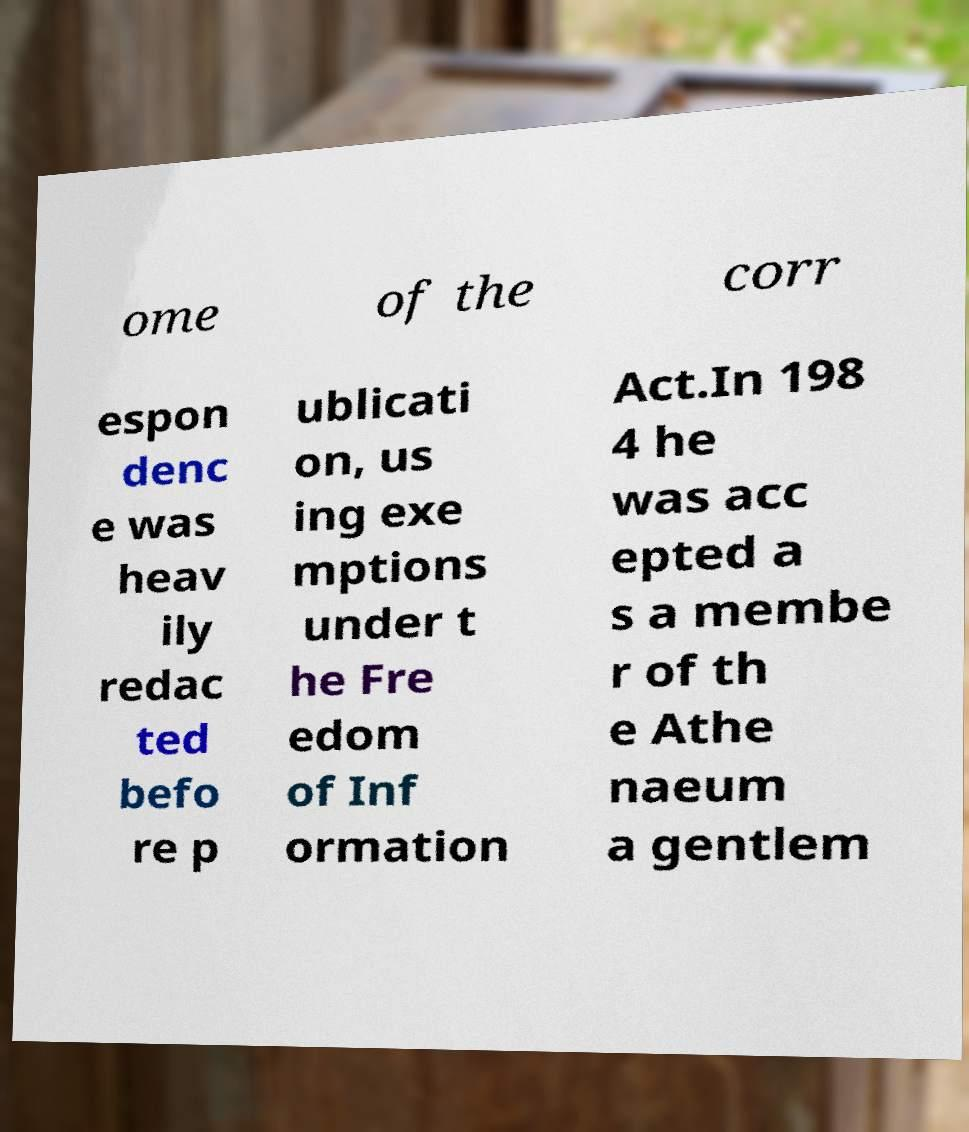Can you accurately transcribe the text from the provided image for me? ome of the corr espon denc e was heav ily redac ted befo re p ublicati on, us ing exe mptions under t he Fre edom of Inf ormation Act.In 198 4 he was acc epted a s a membe r of th e Athe naeum a gentlem 